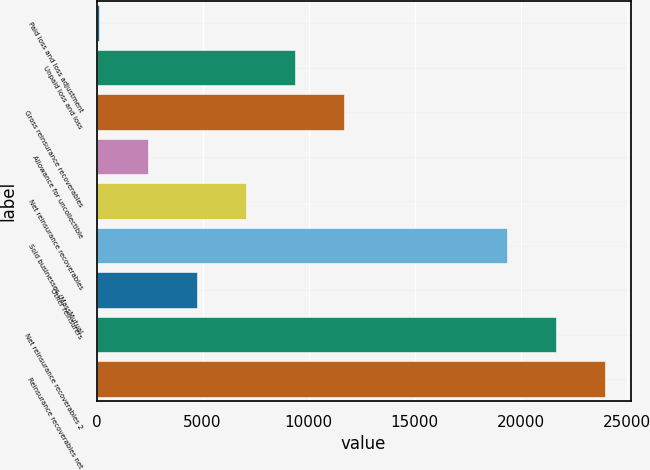Convert chart to OTSL. <chart><loc_0><loc_0><loc_500><loc_500><bar_chart><fcel>Paid loss and loss adjustment<fcel>Unpaid loss and loss<fcel>Gross reinsurance recoverables<fcel>Allowance for uncollectible<fcel>Net reinsurance recoverables<fcel>Sold businesses (MassMutual<fcel>Other reinsurers<fcel>Net reinsurance recoverables 2<fcel>Reinsurance recoverables net<nl><fcel>119<fcel>9347<fcel>11654<fcel>2426<fcel>7040<fcel>19369<fcel>4733<fcel>21676<fcel>23983<nl></chart> 